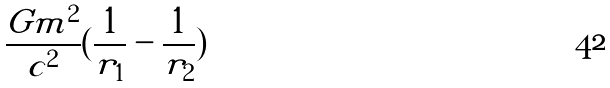Convert formula to latex. <formula><loc_0><loc_0><loc_500><loc_500>\frac { G m ^ { 2 } } { c ^ { 2 } } ( \frac { 1 } { r _ { 1 } } - \frac { 1 } { r _ { 2 } } )</formula> 